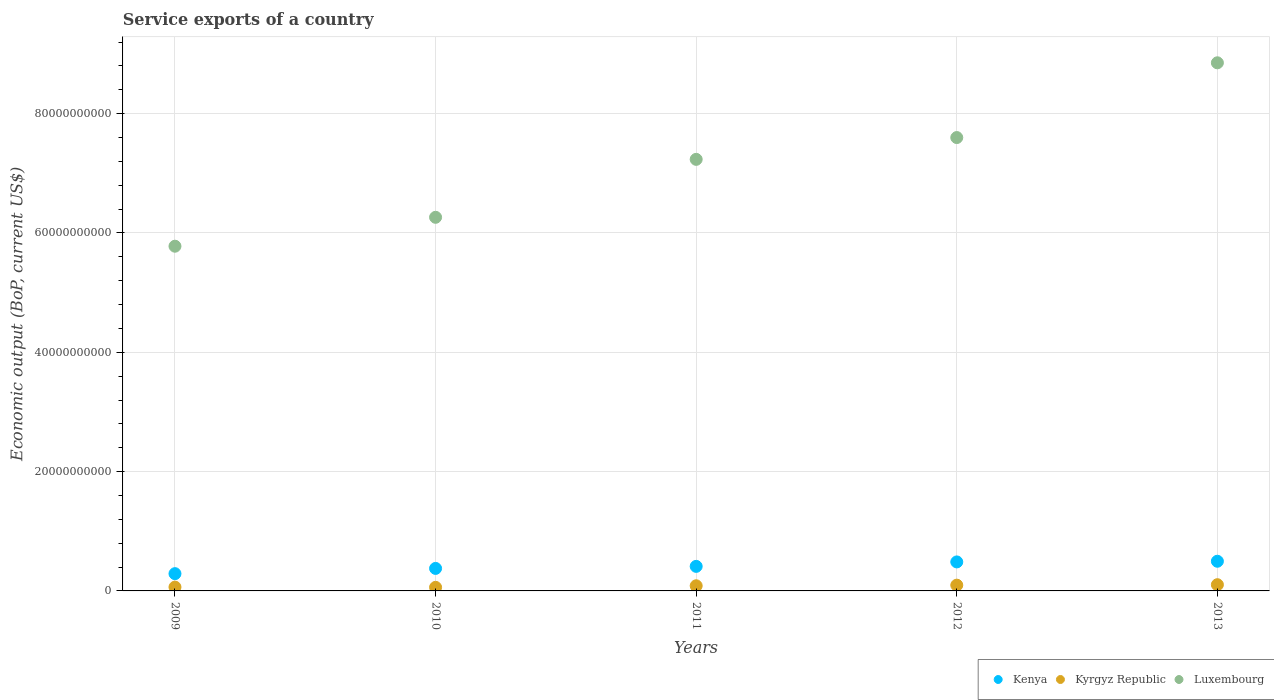What is the service exports in Kyrgyz Republic in 2011?
Your answer should be compact. 8.60e+08. Across all years, what is the maximum service exports in Kyrgyz Republic?
Your answer should be compact. 1.04e+09. Across all years, what is the minimum service exports in Kyrgyz Republic?
Make the answer very short. 6.00e+08. In which year was the service exports in Luxembourg maximum?
Provide a short and direct response. 2013. What is the total service exports in Kenya in the graph?
Your answer should be very brief. 2.06e+1. What is the difference between the service exports in Luxembourg in 2009 and that in 2012?
Provide a short and direct response. -1.82e+1. What is the difference between the service exports in Kenya in 2012 and the service exports in Kyrgyz Republic in 2010?
Ensure brevity in your answer.  4.26e+09. What is the average service exports in Kyrgyz Republic per year?
Ensure brevity in your answer.  8.22e+08. In the year 2013, what is the difference between the service exports in Luxembourg and service exports in Kyrgyz Republic?
Your answer should be very brief. 8.75e+1. In how many years, is the service exports in Luxembourg greater than 44000000000 US$?
Offer a very short reply. 5. What is the ratio of the service exports in Luxembourg in 2011 to that in 2012?
Keep it short and to the point. 0.95. What is the difference between the highest and the second highest service exports in Kenya?
Keep it short and to the point. 1.13e+08. What is the difference between the highest and the lowest service exports in Kenya?
Offer a terse response. 2.08e+09. In how many years, is the service exports in Kenya greater than the average service exports in Kenya taken over all years?
Offer a very short reply. 2. Does the service exports in Luxembourg monotonically increase over the years?
Provide a succinct answer. Yes. How many years are there in the graph?
Your response must be concise. 5. What is the difference between two consecutive major ticks on the Y-axis?
Give a very brief answer. 2.00e+1. Are the values on the major ticks of Y-axis written in scientific E-notation?
Your answer should be very brief. No. Does the graph contain any zero values?
Keep it short and to the point. No. How many legend labels are there?
Your response must be concise. 3. How are the legend labels stacked?
Ensure brevity in your answer.  Horizontal. What is the title of the graph?
Your answer should be compact. Service exports of a country. Does "Jamaica" appear as one of the legend labels in the graph?
Ensure brevity in your answer.  No. What is the label or title of the X-axis?
Offer a terse response. Years. What is the label or title of the Y-axis?
Your response must be concise. Economic output (BoP, current US$). What is the Economic output (BoP, current US$) in Kenya in 2009?
Make the answer very short. 2.89e+09. What is the Economic output (BoP, current US$) in Kyrgyz Republic in 2009?
Your answer should be compact. 6.38e+08. What is the Economic output (BoP, current US$) of Luxembourg in 2009?
Give a very brief answer. 5.78e+1. What is the Economic output (BoP, current US$) in Kenya in 2010?
Your answer should be very brief. 3.77e+09. What is the Economic output (BoP, current US$) of Kyrgyz Republic in 2010?
Offer a very short reply. 6.00e+08. What is the Economic output (BoP, current US$) in Luxembourg in 2010?
Keep it short and to the point. 6.26e+1. What is the Economic output (BoP, current US$) in Kenya in 2011?
Give a very brief answer. 4.11e+09. What is the Economic output (BoP, current US$) in Kyrgyz Republic in 2011?
Offer a very short reply. 8.60e+08. What is the Economic output (BoP, current US$) of Luxembourg in 2011?
Your response must be concise. 7.23e+1. What is the Economic output (BoP, current US$) of Kenya in 2012?
Offer a very short reply. 4.86e+09. What is the Economic output (BoP, current US$) of Kyrgyz Republic in 2012?
Ensure brevity in your answer.  9.67e+08. What is the Economic output (BoP, current US$) of Luxembourg in 2012?
Make the answer very short. 7.60e+1. What is the Economic output (BoP, current US$) of Kenya in 2013?
Offer a very short reply. 4.97e+09. What is the Economic output (BoP, current US$) of Kyrgyz Republic in 2013?
Your answer should be compact. 1.04e+09. What is the Economic output (BoP, current US$) of Luxembourg in 2013?
Provide a succinct answer. 8.85e+1. Across all years, what is the maximum Economic output (BoP, current US$) in Kenya?
Ensure brevity in your answer.  4.97e+09. Across all years, what is the maximum Economic output (BoP, current US$) in Kyrgyz Republic?
Offer a terse response. 1.04e+09. Across all years, what is the maximum Economic output (BoP, current US$) in Luxembourg?
Give a very brief answer. 8.85e+1. Across all years, what is the minimum Economic output (BoP, current US$) of Kenya?
Offer a terse response. 2.89e+09. Across all years, what is the minimum Economic output (BoP, current US$) of Kyrgyz Republic?
Ensure brevity in your answer.  6.00e+08. Across all years, what is the minimum Economic output (BoP, current US$) of Luxembourg?
Keep it short and to the point. 5.78e+1. What is the total Economic output (BoP, current US$) of Kenya in the graph?
Provide a succinct answer. 2.06e+1. What is the total Economic output (BoP, current US$) of Kyrgyz Republic in the graph?
Your response must be concise. 4.11e+09. What is the total Economic output (BoP, current US$) of Luxembourg in the graph?
Provide a succinct answer. 3.57e+11. What is the difference between the Economic output (BoP, current US$) in Kenya in 2009 and that in 2010?
Your response must be concise. -8.79e+08. What is the difference between the Economic output (BoP, current US$) of Kyrgyz Republic in 2009 and that in 2010?
Give a very brief answer. 3.81e+07. What is the difference between the Economic output (BoP, current US$) in Luxembourg in 2009 and that in 2010?
Ensure brevity in your answer.  -4.85e+09. What is the difference between the Economic output (BoP, current US$) in Kenya in 2009 and that in 2011?
Ensure brevity in your answer.  -1.22e+09. What is the difference between the Economic output (BoP, current US$) in Kyrgyz Republic in 2009 and that in 2011?
Your answer should be very brief. -2.22e+08. What is the difference between the Economic output (BoP, current US$) of Luxembourg in 2009 and that in 2011?
Make the answer very short. -1.46e+1. What is the difference between the Economic output (BoP, current US$) of Kenya in 2009 and that in 2012?
Make the answer very short. -1.97e+09. What is the difference between the Economic output (BoP, current US$) in Kyrgyz Republic in 2009 and that in 2012?
Your answer should be very brief. -3.28e+08. What is the difference between the Economic output (BoP, current US$) of Luxembourg in 2009 and that in 2012?
Ensure brevity in your answer.  -1.82e+1. What is the difference between the Economic output (BoP, current US$) in Kenya in 2009 and that in 2013?
Give a very brief answer. -2.08e+09. What is the difference between the Economic output (BoP, current US$) in Kyrgyz Republic in 2009 and that in 2013?
Offer a very short reply. -4.04e+08. What is the difference between the Economic output (BoP, current US$) of Luxembourg in 2009 and that in 2013?
Your answer should be compact. -3.07e+1. What is the difference between the Economic output (BoP, current US$) of Kenya in 2010 and that in 2011?
Provide a short and direct response. -3.42e+08. What is the difference between the Economic output (BoP, current US$) in Kyrgyz Republic in 2010 and that in 2011?
Give a very brief answer. -2.60e+08. What is the difference between the Economic output (BoP, current US$) of Luxembourg in 2010 and that in 2011?
Ensure brevity in your answer.  -9.71e+09. What is the difference between the Economic output (BoP, current US$) in Kenya in 2010 and that in 2012?
Provide a succinct answer. -1.09e+09. What is the difference between the Economic output (BoP, current US$) in Kyrgyz Republic in 2010 and that in 2012?
Offer a very short reply. -3.66e+08. What is the difference between the Economic output (BoP, current US$) of Luxembourg in 2010 and that in 2012?
Provide a succinct answer. -1.34e+1. What is the difference between the Economic output (BoP, current US$) in Kenya in 2010 and that in 2013?
Ensure brevity in your answer.  -1.20e+09. What is the difference between the Economic output (BoP, current US$) in Kyrgyz Republic in 2010 and that in 2013?
Offer a very short reply. -4.43e+08. What is the difference between the Economic output (BoP, current US$) in Luxembourg in 2010 and that in 2013?
Provide a succinct answer. -2.59e+1. What is the difference between the Economic output (BoP, current US$) in Kenya in 2011 and that in 2012?
Your answer should be very brief. -7.46e+08. What is the difference between the Economic output (BoP, current US$) in Kyrgyz Republic in 2011 and that in 2012?
Give a very brief answer. -1.06e+08. What is the difference between the Economic output (BoP, current US$) in Luxembourg in 2011 and that in 2012?
Make the answer very short. -3.65e+09. What is the difference between the Economic output (BoP, current US$) in Kenya in 2011 and that in 2013?
Your answer should be very brief. -8.59e+08. What is the difference between the Economic output (BoP, current US$) in Kyrgyz Republic in 2011 and that in 2013?
Your answer should be compact. -1.82e+08. What is the difference between the Economic output (BoP, current US$) in Luxembourg in 2011 and that in 2013?
Offer a very short reply. -1.62e+1. What is the difference between the Economic output (BoP, current US$) in Kenya in 2012 and that in 2013?
Keep it short and to the point. -1.13e+08. What is the difference between the Economic output (BoP, current US$) of Kyrgyz Republic in 2012 and that in 2013?
Provide a short and direct response. -7.61e+07. What is the difference between the Economic output (BoP, current US$) of Luxembourg in 2012 and that in 2013?
Offer a very short reply. -1.25e+1. What is the difference between the Economic output (BoP, current US$) of Kenya in 2009 and the Economic output (BoP, current US$) of Kyrgyz Republic in 2010?
Offer a very short reply. 2.29e+09. What is the difference between the Economic output (BoP, current US$) in Kenya in 2009 and the Economic output (BoP, current US$) in Luxembourg in 2010?
Ensure brevity in your answer.  -5.97e+1. What is the difference between the Economic output (BoP, current US$) of Kyrgyz Republic in 2009 and the Economic output (BoP, current US$) of Luxembourg in 2010?
Your response must be concise. -6.20e+1. What is the difference between the Economic output (BoP, current US$) of Kenya in 2009 and the Economic output (BoP, current US$) of Kyrgyz Republic in 2011?
Give a very brief answer. 2.03e+09. What is the difference between the Economic output (BoP, current US$) of Kenya in 2009 and the Economic output (BoP, current US$) of Luxembourg in 2011?
Give a very brief answer. -6.94e+1. What is the difference between the Economic output (BoP, current US$) in Kyrgyz Republic in 2009 and the Economic output (BoP, current US$) in Luxembourg in 2011?
Give a very brief answer. -7.17e+1. What is the difference between the Economic output (BoP, current US$) in Kenya in 2009 and the Economic output (BoP, current US$) in Kyrgyz Republic in 2012?
Your response must be concise. 1.93e+09. What is the difference between the Economic output (BoP, current US$) of Kenya in 2009 and the Economic output (BoP, current US$) of Luxembourg in 2012?
Provide a short and direct response. -7.31e+1. What is the difference between the Economic output (BoP, current US$) of Kyrgyz Republic in 2009 and the Economic output (BoP, current US$) of Luxembourg in 2012?
Provide a short and direct response. -7.53e+1. What is the difference between the Economic output (BoP, current US$) in Kenya in 2009 and the Economic output (BoP, current US$) in Kyrgyz Republic in 2013?
Offer a terse response. 1.85e+09. What is the difference between the Economic output (BoP, current US$) of Kenya in 2009 and the Economic output (BoP, current US$) of Luxembourg in 2013?
Ensure brevity in your answer.  -8.56e+1. What is the difference between the Economic output (BoP, current US$) in Kyrgyz Republic in 2009 and the Economic output (BoP, current US$) in Luxembourg in 2013?
Make the answer very short. -8.79e+1. What is the difference between the Economic output (BoP, current US$) in Kenya in 2010 and the Economic output (BoP, current US$) in Kyrgyz Republic in 2011?
Offer a very short reply. 2.91e+09. What is the difference between the Economic output (BoP, current US$) of Kenya in 2010 and the Economic output (BoP, current US$) of Luxembourg in 2011?
Your answer should be very brief. -6.86e+1. What is the difference between the Economic output (BoP, current US$) in Kyrgyz Republic in 2010 and the Economic output (BoP, current US$) in Luxembourg in 2011?
Give a very brief answer. -7.17e+1. What is the difference between the Economic output (BoP, current US$) in Kenya in 2010 and the Economic output (BoP, current US$) in Kyrgyz Republic in 2012?
Offer a terse response. 2.81e+09. What is the difference between the Economic output (BoP, current US$) in Kenya in 2010 and the Economic output (BoP, current US$) in Luxembourg in 2012?
Make the answer very short. -7.22e+1. What is the difference between the Economic output (BoP, current US$) in Kyrgyz Republic in 2010 and the Economic output (BoP, current US$) in Luxembourg in 2012?
Your answer should be compact. -7.54e+1. What is the difference between the Economic output (BoP, current US$) in Kenya in 2010 and the Economic output (BoP, current US$) in Kyrgyz Republic in 2013?
Offer a very short reply. 2.73e+09. What is the difference between the Economic output (BoP, current US$) in Kenya in 2010 and the Economic output (BoP, current US$) in Luxembourg in 2013?
Offer a very short reply. -8.47e+1. What is the difference between the Economic output (BoP, current US$) of Kyrgyz Republic in 2010 and the Economic output (BoP, current US$) of Luxembourg in 2013?
Offer a terse response. -8.79e+1. What is the difference between the Economic output (BoP, current US$) in Kenya in 2011 and the Economic output (BoP, current US$) in Kyrgyz Republic in 2012?
Offer a terse response. 3.15e+09. What is the difference between the Economic output (BoP, current US$) in Kenya in 2011 and the Economic output (BoP, current US$) in Luxembourg in 2012?
Your answer should be compact. -7.19e+1. What is the difference between the Economic output (BoP, current US$) of Kyrgyz Republic in 2011 and the Economic output (BoP, current US$) of Luxembourg in 2012?
Give a very brief answer. -7.51e+1. What is the difference between the Economic output (BoP, current US$) in Kenya in 2011 and the Economic output (BoP, current US$) in Kyrgyz Republic in 2013?
Your answer should be very brief. 3.07e+09. What is the difference between the Economic output (BoP, current US$) of Kenya in 2011 and the Economic output (BoP, current US$) of Luxembourg in 2013?
Provide a succinct answer. -8.44e+1. What is the difference between the Economic output (BoP, current US$) in Kyrgyz Republic in 2011 and the Economic output (BoP, current US$) in Luxembourg in 2013?
Keep it short and to the point. -8.77e+1. What is the difference between the Economic output (BoP, current US$) in Kenya in 2012 and the Economic output (BoP, current US$) in Kyrgyz Republic in 2013?
Provide a short and direct response. 3.82e+09. What is the difference between the Economic output (BoP, current US$) in Kenya in 2012 and the Economic output (BoP, current US$) in Luxembourg in 2013?
Offer a very short reply. -8.37e+1. What is the difference between the Economic output (BoP, current US$) of Kyrgyz Republic in 2012 and the Economic output (BoP, current US$) of Luxembourg in 2013?
Offer a very short reply. -8.76e+1. What is the average Economic output (BoP, current US$) of Kenya per year?
Make the answer very short. 4.12e+09. What is the average Economic output (BoP, current US$) in Kyrgyz Republic per year?
Your answer should be very brief. 8.22e+08. What is the average Economic output (BoP, current US$) in Luxembourg per year?
Provide a short and direct response. 7.14e+1. In the year 2009, what is the difference between the Economic output (BoP, current US$) of Kenya and Economic output (BoP, current US$) of Kyrgyz Republic?
Your answer should be very brief. 2.25e+09. In the year 2009, what is the difference between the Economic output (BoP, current US$) of Kenya and Economic output (BoP, current US$) of Luxembourg?
Your answer should be compact. -5.49e+1. In the year 2009, what is the difference between the Economic output (BoP, current US$) of Kyrgyz Republic and Economic output (BoP, current US$) of Luxembourg?
Offer a very short reply. -5.71e+1. In the year 2010, what is the difference between the Economic output (BoP, current US$) in Kenya and Economic output (BoP, current US$) in Kyrgyz Republic?
Make the answer very short. 3.17e+09. In the year 2010, what is the difference between the Economic output (BoP, current US$) of Kenya and Economic output (BoP, current US$) of Luxembourg?
Offer a terse response. -5.88e+1. In the year 2010, what is the difference between the Economic output (BoP, current US$) of Kyrgyz Republic and Economic output (BoP, current US$) of Luxembourg?
Ensure brevity in your answer.  -6.20e+1. In the year 2011, what is the difference between the Economic output (BoP, current US$) in Kenya and Economic output (BoP, current US$) in Kyrgyz Republic?
Offer a terse response. 3.25e+09. In the year 2011, what is the difference between the Economic output (BoP, current US$) in Kenya and Economic output (BoP, current US$) in Luxembourg?
Ensure brevity in your answer.  -6.82e+1. In the year 2011, what is the difference between the Economic output (BoP, current US$) of Kyrgyz Republic and Economic output (BoP, current US$) of Luxembourg?
Make the answer very short. -7.15e+1. In the year 2012, what is the difference between the Economic output (BoP, current US$) in Kenya and Economic output (BoP, current US$) in Kyrgyz Republic?
Keep it short and to the point. 3.89e+09. In the year 2012, what is the difference between the Economic output (BoP, current US$) of Kenya and Economic output (BoP, current US$) of Luxembourg?
Provide a short and direct response. -7.11e+1. In the year 2012, what is the difference between the Economic output (BoP, current US$) in Kyrgyz Republic and Economic output (BoP, current US$) in Luxembourg?
Offer a very short reply. -7.50e+1. In the year 2013, what is the difference between the Economic output (BoP, current US$) of Kenya and Economic output (BoP, current US$) of Kyrgyz Republic?
Ensure brevity in your answer.  3.93e+09. In the year 2013, what is the difference between the Economic output (BoP, current US$) of Kenya and Economic output (BoP, current US$) of Luxembourg?
Make the answer very short. -8.35e+1. In the year 2013, what is the difference between the Economic output (BoP, current US$) of Kyrgyz Republic and Economic output (BoP, current US$) of Luxembourg?
Offer a terse response. -8.75e+1. What is the ratio of the Economic output (BoP, current US$) of Kenya in 2009 to that in 2010?
Keep it short and to the point. 0.77. What is the ratio of the Economic output (BoP, current US$) in Kyrgyz Republic in 2009 to that in 2010?
Ensure brevity in your answer.  1.06. What is the ratio of the Economic output (BoP, current US$) of Luxembourg in 2009 to that in 2010?
Give a very brief answer. 0.92. What is the ratio of the Economic output (BoP, current US$) in Kenya in 2009 to that in 2011?
Keep it short and to the point. 0.7. What is the ratio of the Economic output (BoP, current US$) of Kyrgyz Republic in 2009 to that in 2011?
Your response must be concise. 0.74. What is the ratio of the Economic output (BoP, current US$) in Luxembourg in 2009 to that in 2011?
Give a very brief answer. 0.8. What is the ratio of the Economic output (BoP, current US$) of Kenya in 2009 to that in 2012?
Your answer should be very brief. 0.6. What is the ratio of the Economic output (BoP, current US$) of Kyrgyz Republic in 2009 to that in 2012?
Keep it short and to the point. 0.66. What is the ratio of the Economic output (BoP, current US$) of Luxembourg in 2009 to that in 2012?
Offer a very short reply. 0.76. What is the ratio of the Economic output (BoP, current US$) in Kenya in 2009 to that in 2013?
Your answer should be compact. 0.58. What is the ratio of the Economic output (BoP, current US$) in Kyrgyz Republic in 2009 to that in 2013?
Keep it short and to the point. 0.61. What is the ratio of the Economic output (BoP, current US$) of Luxembourg in 2009 to that in 2013?
Make the answer very short. 0.65. What is the ratio of the Economic output (BoP, current US$) of Kenya in 2010 to that in 2011?
Keep it short and to the point. 0.92. What is the ratio of the Economic output (BoP, current US$) in Kyrgyz Republic in 2010 to that in 2011?
Offer a terse response. 0.7. What is the ratio of the Economic output (BoP, current US$) of Luxembourg in 2010 to that in 2011?
Offer a terse response. 0.87. What is the ratio of the Economic output (BoP, current US$) of Kenya in 2010 to that in 2012?
Make the answer very short. 0.78. What is the ratio of the Economic output (BoP, current US$) of Kyrgyz Republic in 2010 to that in 2012?
Provide a succinct answer. 0.62. What is the ratio of the Economic output (BoP, current US$) of Luxembourg in 2010 to that in 2012?
Give a very brief answer. 0.82. What is the ratio of the Economic output (BoP, current US$) in Kenya in 2010 to that in 2013?
Make the answer very short. 0.76. What is the ratio of the Economic output (BoP, current US$) of Kyrgyz Republic in 2010 to that in 2013?
Offer a terse response. 0.58. What is the ratio of the Economic output (BoP, current US$) of Luxembourg in 2010 to that in 2013?
Provide a short and direct response. 0.71. What is the ratio of the Economic output (BoP, current US$) of Kenya in 2011 to that in 2012?
Your response must be concise. 0.85. What is the ratio of the Economic output (BoP, current US$) in Kyrgyz Republic in 2011 to that in 2012?
Provide a short and direct response. 0.89. What is the ratio of the Economic output (BoP, current US$) of Luxembourg in 2011 to that in 2012?
Provide a short and direct response. 0.95. What is the ratio of the Economic output (BoP, current US$) of Kenya in 2011 to that in 2013?
Your answer should be compact. 0.83. What is the ratio of the Economic output (BoP, current US$) in Kyrgyz Republic in 2011 to that in 2013?
Make the answer very short. 0.82. What is the ratio of the Economic output (BoP, current US$) in Luxembourg in 2011 to that in 2013?
Ensure brevity in your answer.  0.82. What is the ratio of the Economic output (BoP, current US$) in Kenya in 2012 to that in 2013?
Your answer should be very brief. 0.98. What is the ratio of the Economic output (BoP, current US$) in Kyrgyz Republic in 2012 to that in 2013?
Provide a succinct answer. 0.93. What is the ratio of the Economic output (BoP, current US$) in Luxembourg in 2012 to that in 2013?
Your answer should be compact. 0.86. What is the difference between the highest and the second highest Economic output (BoP, current US$) of Kenya?
Your answer should be very brief. 1.13e+08. What is the difference between the highest and the second highest Economic output (BoP, current US$) in Kyrgyz Republic?
Your answer should be very brief. 7.61e+07. What is the difference between the highest and the second highest Economic output (BoP, current US$) in Luxembourg?
Offer a very short reply. 1.25e+1. What is the difference between the highest and the lowest Economic output (BoP, current US$) of Kenya?
Give a very brief answer. 2.08e+09. What is the difference between the highest and the lowest Economic output (BoP, current US$) of Kyrgyz Republic?
Offer a terse response. 4.43e+08. What is the difference between the highest and the lowest Economic output (BoP, current US$) in Luxembourg?
Offer a very short reply. 3.07e+1. 